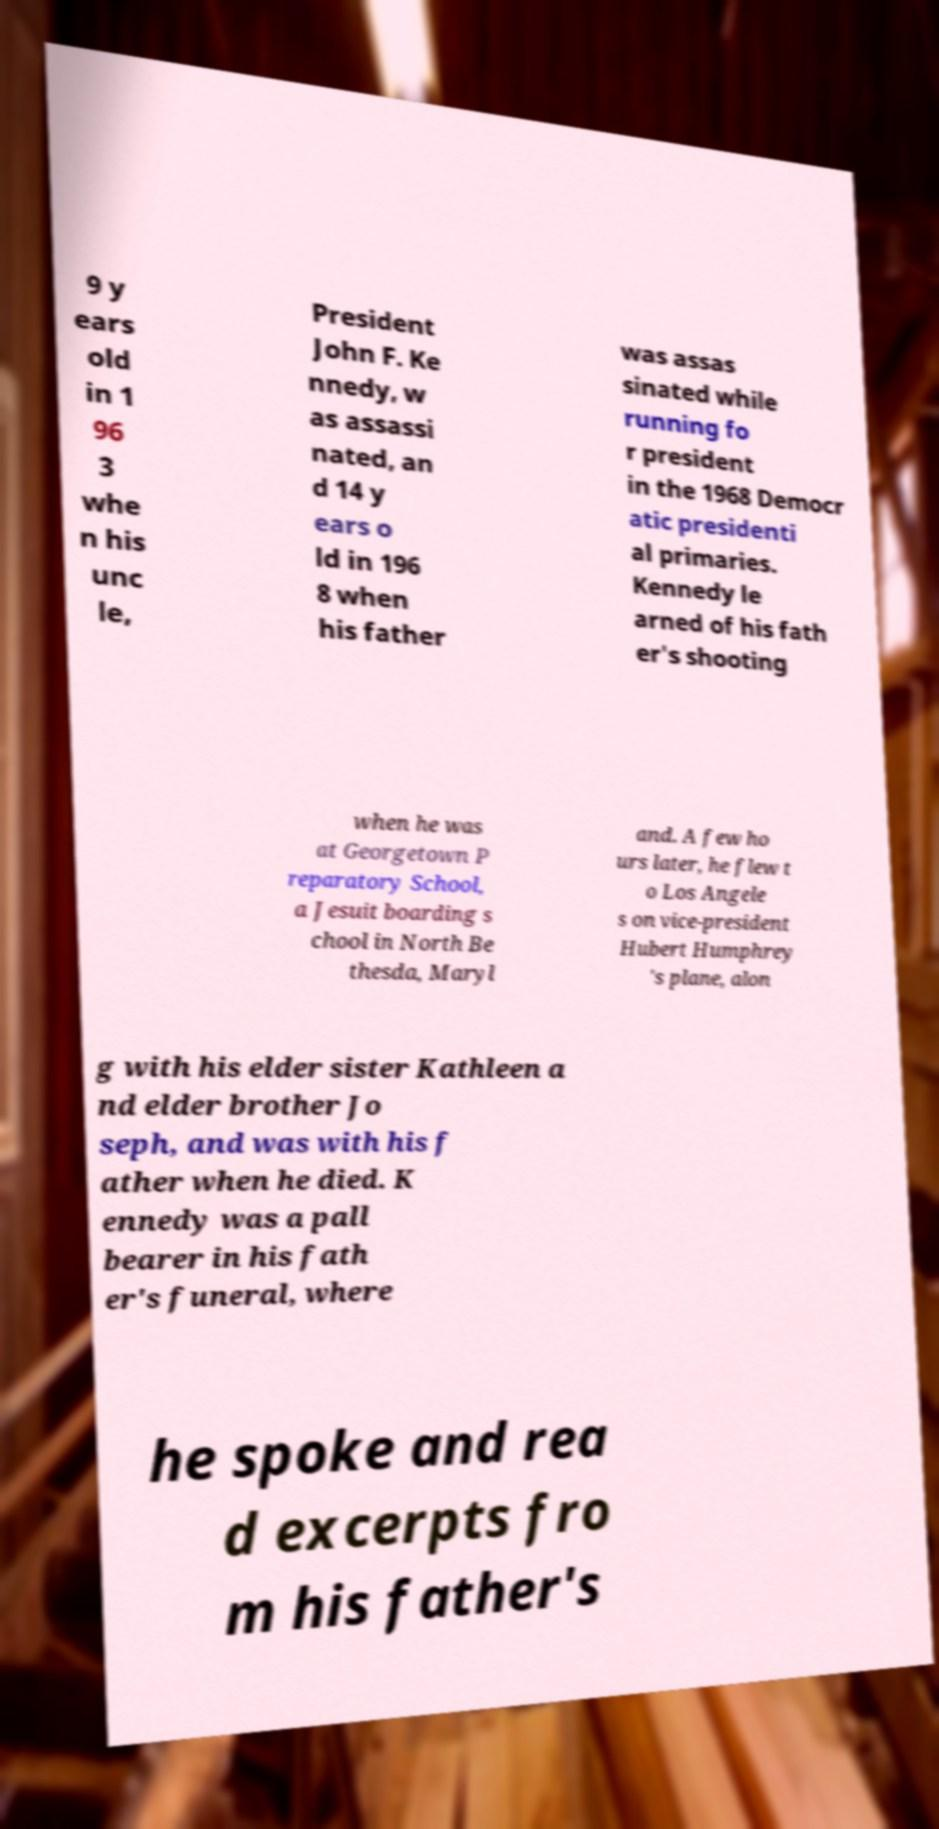For documentation purposes, I need the text within this image transcribed. Could you provide that? 9 y ears old in 1 96 3 whe n his unc le, President John F. Ke nnedy, w as assassi nated, an d 14 y ears o ld in 196 8 when his father was assas sinated while running fo r president in the 1968 Democr atic presidenti al primaries. Kennedy le arned of his fath er's shooting when he was at Georgetown P reparatory School, a Jesuit boarding s chool in North Be thesda, Maryl and. A few ho urs later, he flew t o Los Angele s on vice-president Hubert Humphrey 's plane, alon g with his elder sister Kathleen a nd elder brother Jo seph, and was with his f ather when he died. K ennedy was a pall bearer in his fath er's funeral, where he spoke and rea d excerpts fro m his father's 